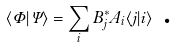<formula> <loc_0><loc_0><loc_500><loc_500>\langle \Phi | \Psi \rangle = \sum _ { i } B _ { j } ^ { * } A _ { i } \langle j | i \rangle \text { .}</formula> 